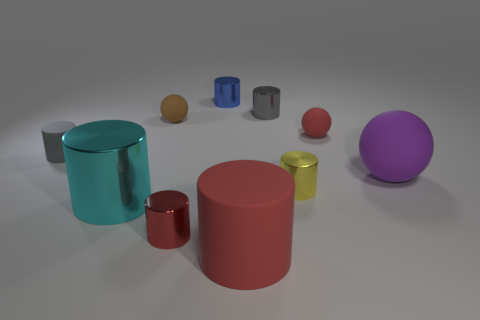There is a cylinder to the left of the cyan object; what size is it?
Provide a succinct answer. Small. How many balls are behind the red object behind the rubber cylinder behind the large purple matte thing?
Offer a terse response. 1. Do the large rubber ball and the big metallic object have the same color?
Your answer should be compact. No. What number of metal things are both on the right side of the brown matte thing and behind the red shiny object?
Give a very brief answer. 3. What is the shape of the gray thing behind the brown thing?
Your answer should be compact. Cylinder. Are there fewer big purple spheres on the left side of the small brown thing than tiny gray things that are right of the small red metallic cylinder?
Give a very brief answer. Yes. Do the small red thing in front of the purple rubber ball and the tiny gray cylinder to the right of the blue metallic cylinder have the same material?
Keep it short and to the point. Yes. What shape is the tiny gray metal thing?
Offer a very short reply. Cylinder. Is the number of rubber objects left of the large shiny cylinder greater than the number of big purple rubber spheres that are behind the tiny blue shiny object?
Make the answer very short. Yes. There is a small yellow object that is behind the big cyan shiny object; does it have the same shape as the small matte object that is on the left side of the big metallic thing?
Provide a short and direct response. Yes. 